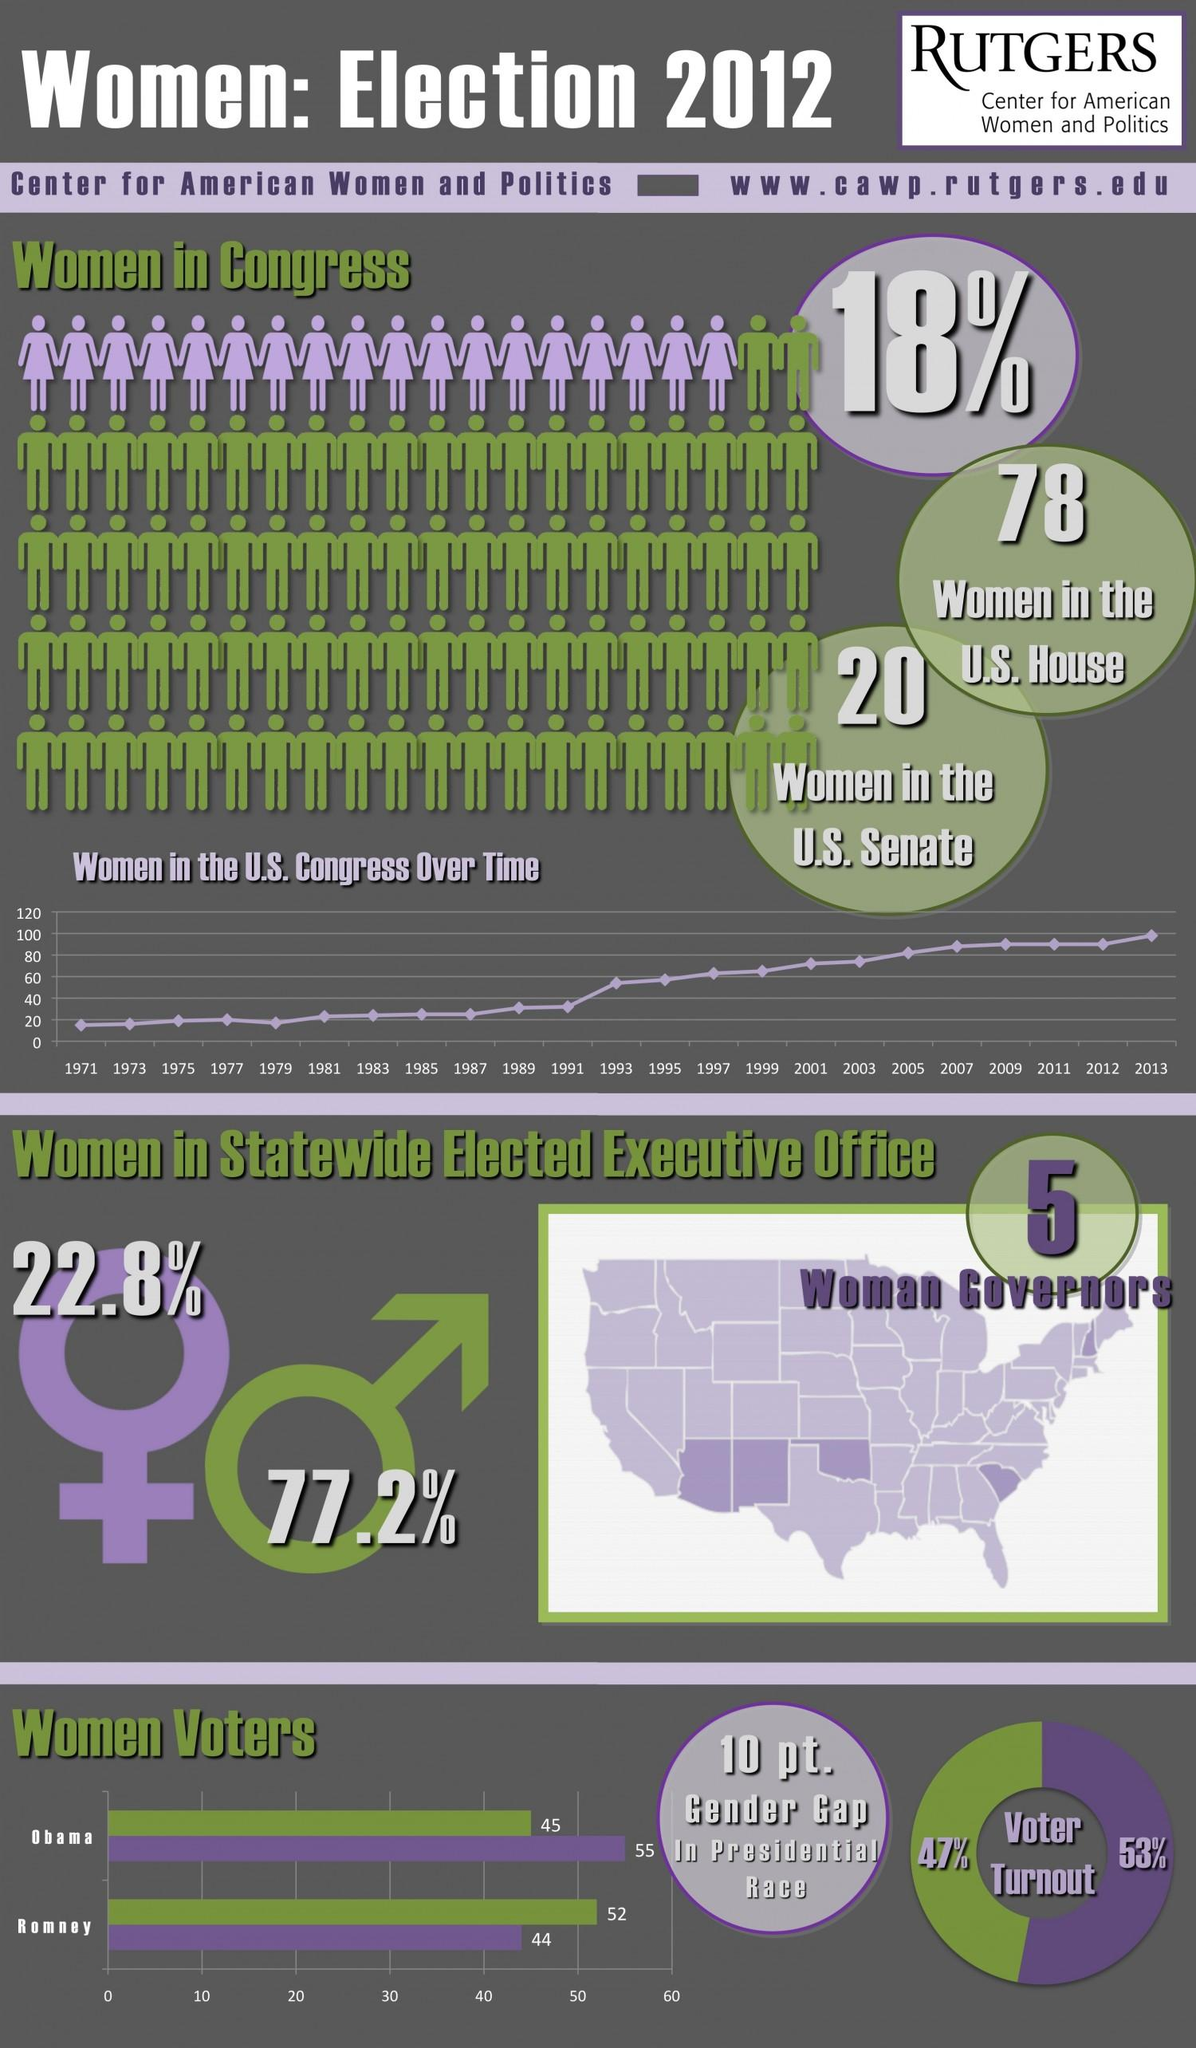Mention a couple of crucial points in this snapshot. In the 2012 U.S. Presidential election, 53% of eligible women were able to cast their vote. In the 2012 U.S. Presidential election, 55% of women voted for Obama. In the 2012 U.S. Presidential election, 47% of eligible men were able to cast their vote. In 2012, women held only 22.8% of statewide elected executive offices in the United States. In 2012, an estimated 82% of the men serving in the United States Congress were represented. 